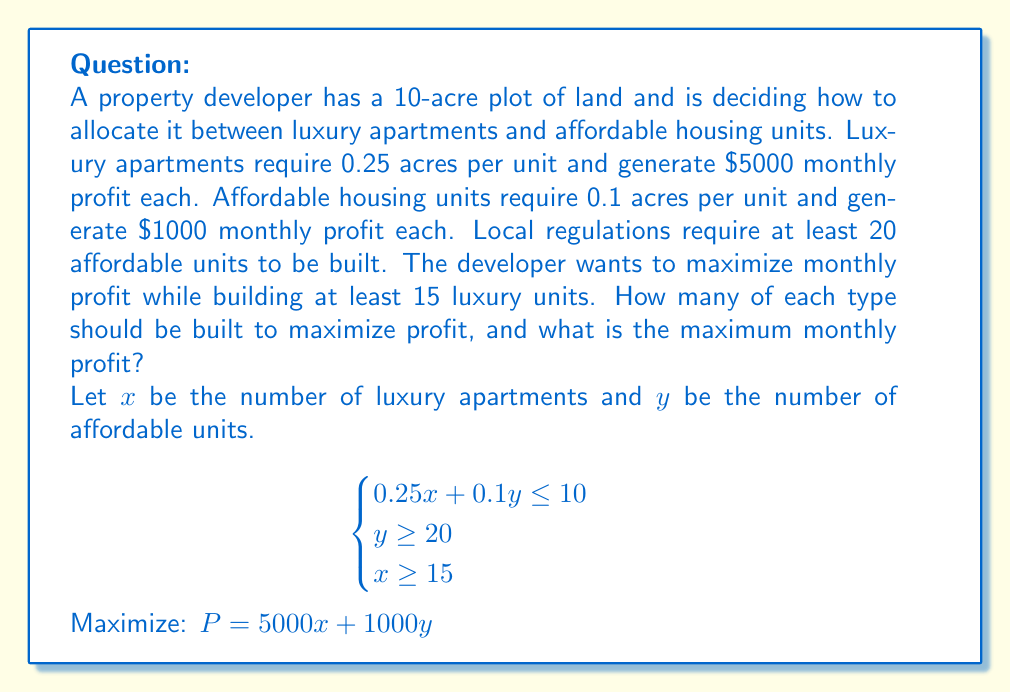Give your solution to this math problem. 1) First, let's graph the constraints:

[asy]
import graph;
size(200);
xaxis("Luxury Units (x)", 0, 45, Arrow);
yaxis("Affordable Units (y)", 0, 110, Arrow);

draw((0,100)--(40,0), blue);
draw((15,0)--(15,110), red);
draw((0,20)--(45,20), green);

label("0.25x + 0.1y = 10", (20,50), E, blue);
label("x = 15", (15,55), W, red);
label("y = 20", (22.5,20), N, green);

fill((15,20)--(15,100)--(40,0)--(15,0)--cycle, lightgray+opacity(0.2));
dot((15,20));
dot((15,100));
dot((40,0));

label("Feasible Region", (25,40), NE);
[/asy]

2) The feasible region is the shaded area. The optimal solution will be at one of the corner points.

3) Corner points are: (15, 20), (15, 100), and (40, 0)

4) Let's evaluate the profit function at each point:
   At (15, 20): $P = 5000(15) + 1000(20) = 95,000$
   At (15, 100): $P = 5000(15) + 1000(100) = 175,000$
   At (40, 0): $P = 5000(40) + 1000(0) = 200,000$ (but this violates y ≥ 20)

5) The point (15, 100) gives the maximum profit while satisfying all constraints.

6) Therefore, the developer should build 15 luxury apartments and 100 affordable units.

7) The maximum monthly profit is $175,000.
Answer: 15 luxury apartments, 100 affordable units; $175,000 monthly profit 